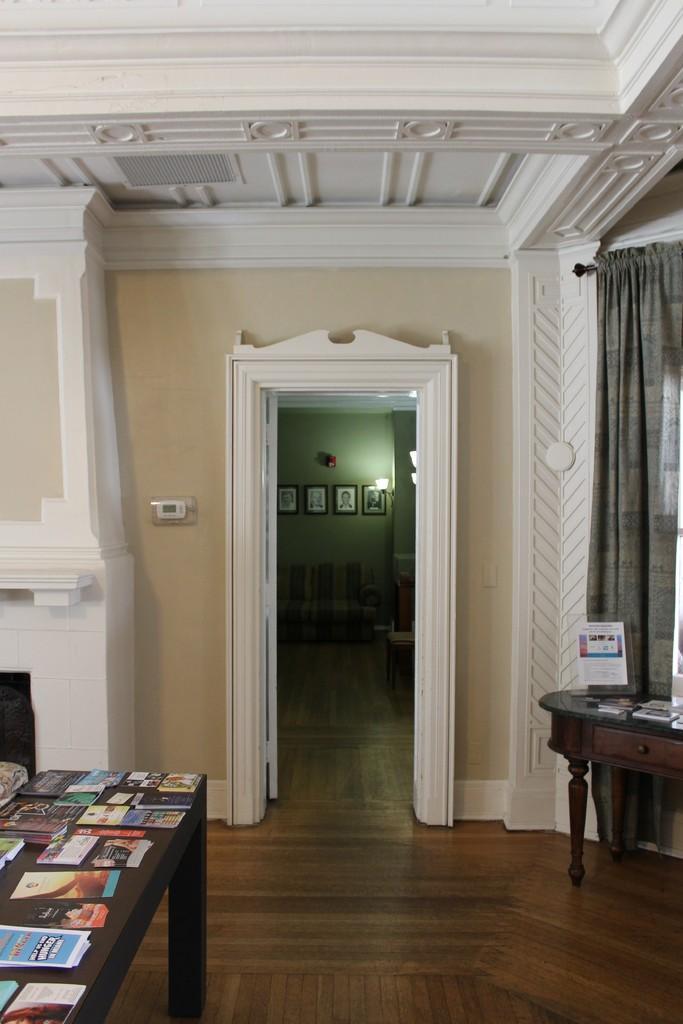Could you give a brief overview of what you see in this image? This picture is clicked inside the room. In the left bottom of the picture, we see a table on which books and papers are placed. Beside that, we see a white wall and beside that, we see a door from which we can see a green wall. We even see many photo frames are placed on that wall. On the right corner of the picture, we see a curtain in grey color and we even see a table on which books are placed. 